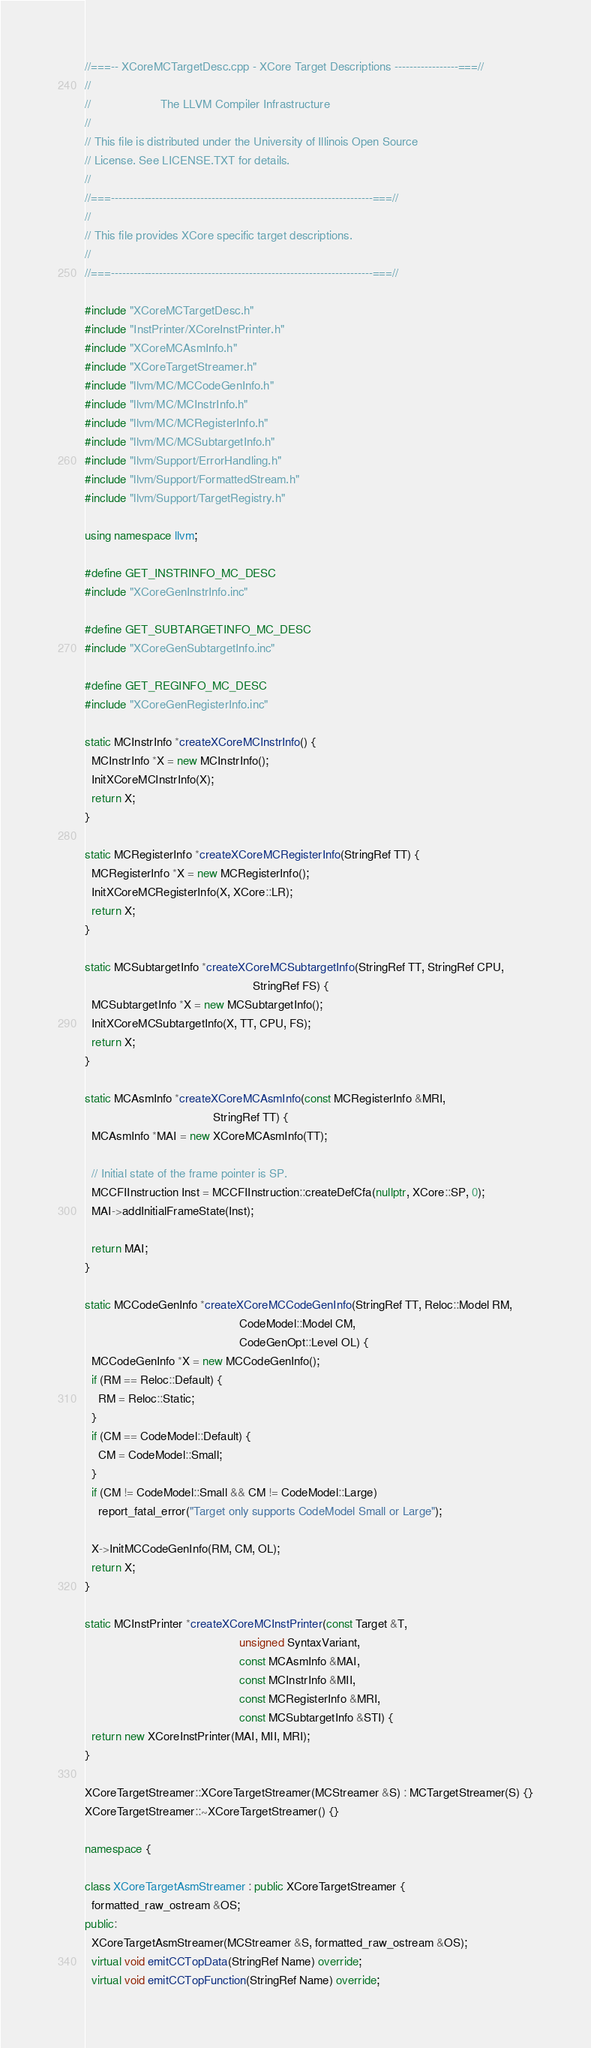<code> <loc_0><loc_0><loc_500><loc_500><_C++_>//===-- XCoreMCTargetDesc.cpp - XCore Target Descriptions -----------------===//
//
//                     The LLVM Compiler Infrastructure
//
// This file is distributed under the University of Illinois Open Source
// License. See LICENSE.TXT for details.
//
//===----------------------------------------------------------------------===//
//
// This file provides XCore specific target descriptions.
//
//===----------------------------------------------------------------------===//

#include "XCoreMCTargetDesc.h"
#include "InstPrinter/XCoreInstPrinter.h"
#include "XCoreMCAsmInfo.h"
#include "XCoreTargetStreamer.h"
#include "llvm/MC/MCCodeGenInfo.h"
#include "llvm/MC/MCInstrInfo.h"
#include "llvm/MC/MCRegisterInfo.h"
#include "llvm/MC/MCSubtargetInfo.h"
#include "llvm/Support/ErrorHandling.h"
#include "llvm/Support/FormattedStream.h"
#include "llvm/Support/TargetRegistry.h"

using namespace llvm;

#define GET_INSTRINFO_MC_DESC
#include "XCoreGenInstrInfo.inc"

#define GET_SUBTARGETINFO_MC_DESC
#include "XCoreGenSubtargetInfo.inc"

#define GET_REGINFO_MC_DESC
#include "XCoreGenRegisterInfo.inc"

static MCInstrInfo *createXCoreMCInstrInfo() {
  MCInstrInfo *X = new MCInstrInfo();
  InitXCoreMCInstrInfo(X);
  return X;
}

static MCRegisterInfo *createXCoreMCRegisterInfo(StringRef TT) {
  MCRegisterInfo *X = new MCRegisterInfo();
  InitXCoreMCRegisterInfo(X, XCore::LR);
  return X;
}

static MCSubtargetInfo *createXCoreMCSubtargetInfo(StringRef TT, StringRef CPU,
                                                   StringRef FS) {
  MCSubtargetInfo *X = new MCSubtargetInfo();
  InitXCoreMCSubtargetInfo(X, TT, CPU, FS);
  return X;
}

static MCAsmInfo *createXCoreMCAsmInfo(const MCRegisterInfo &MRI,
                                       StringRef TT) {
  MCAsmInfo *MAI = new XCoreMCAsmInfo(TT);

  // Initial state of the frame pointer is SP.
  MCCFIInstruction Inst = MCCFIInstruction::createDefCfa(nullptr, XCore::SP, 0);
  MAI->addInitialFrameState(Inst);

  return MAI;
}

static MCCodeGenInfo *createXCoreMCCodeGenInfo(StringRef TT, Reloc::Model RM,
                                               CodeModel::Model CM,
                                               CodeGenOpt::Level OL) {
  MCCodeGenInfo *X = new MCCodeGenInfo();
  if (RM == Reloc::Default) {
    RM = Reloc::Static;
  }
  if (CM == CodeModel::Default) {
    CM = CodeModel::Small;
  }
  if (CM != CodeModel::Small && CM != CodeModel::Large)
    report_fatal_error("Target only supports CodeModel Small or Large");

  X->InitMCCodeGenInfo(RM, CM, OL);
  return X;
}

static MCInstPrinter *createXCoreMCInstPrinter(const Target &T,
                                               unsigned SyntaxVariant,
                                               const MCAsmInfo &MAI,
                                               const MCInstrInfo &MII,
                                               const MCRegisterInfo &MRI,
                                               const MCSubtargetInfo &STI) {
  return new XCoreInstPrinter(MAI, MII, MRI);
}

XCoreTargetStreamer::XCoreTargetStreamer(MCStreamer &S) : MCTargetStreamer(S) {}
XCoreTargetStreamer::~XCoreTargetStreamer() {}

namespace {

class XCoreTargetAsmStreamer : public XCoreTargetStreamer {
  formatted_raw_ostream &OS;
public:
  XCoreTargetAsmStreamer(MCStreamer &S, formatted_raw_ostream &OS);
  virtual void emitCCTopData(StringRef Name) override;
  virtual void emitCCTopFunction(StringRef Name) override;</code> 